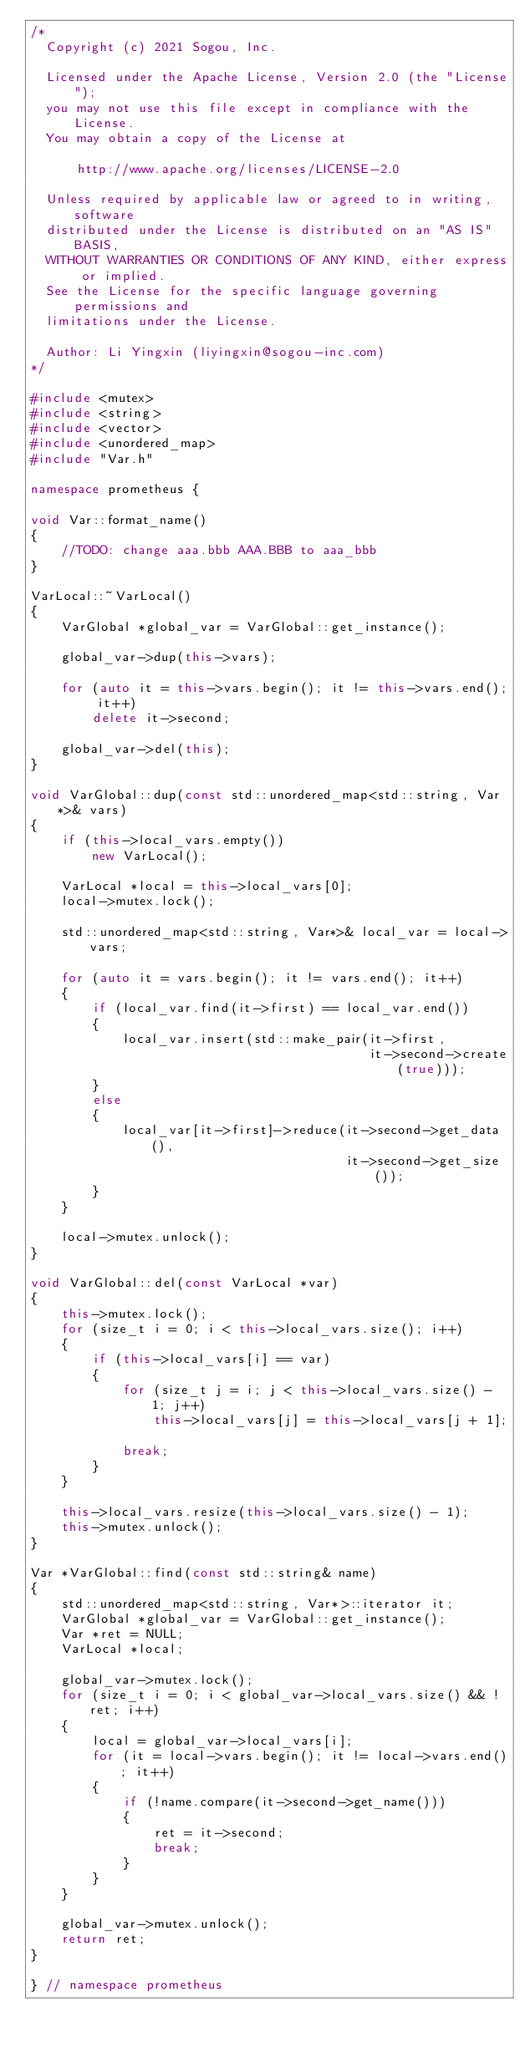Convert code to text. <code><loc_0><loc_0><loc_500><loc_500><_C++_>/*
  Copyright (c) 2021 Sogou, Inc.

  Licensed under the Apache License, Version 2.0 (the "License");
  you may not use this file except in compliance with the License.
  You may obtain a copy of the License at

      http://www.apache.org/licenses/LICENSE-2.0

  Unless required by applicable law or agreed to in writing, software
  distributed under the License is distributed on an "AS IS" BASIS,
  WITHOUT WARRANTIES OR CONDITIONS OF ANY KIND, either express or implied.
  See the License for the specific language governing permissions and
  limitations under the License.

  Author: Li Yingxin (liyingxin@sogou-inc.com)
*/

#include <mutex>
#include <string>
#include <vector>
#include <unordered_map>
#include "Var.h"

namespace prometheus {

void Var::format_name()
{
	//TODO: change aaa.bbb AAA.BBB to aaa_bbb
}

VarLocal::~VarLocal()
{
	VarGlobal *global_var = VarGlobal::get_instance();

	global_var->dup(this->vars);

	for (auto it = this->vars.begin(); it != this->vars.end(); it++)
		delete it->second;

	global_var->del(this);
}

void VarGlobal::dup(const std::unordered_map<std::string, Var *>& vars)
{
	if (this->local_vars.empty())
		new VarLocal();

	VarLocal *local = this->local_vars[0];
	local->mutex.lock();

	std::unordered_map<std::string, Var*>& local_var = local->vars;

	for (auto it = vars.begin(); it != vars.end(); it++)
	{
		if (local_var.find(it->first) == local_var.end())
		{
			local_var.insert(std::make_pair(it->first,
											it->second->create(true)));
		}
		else
		{
			local_var[it->first]->reduce(it->second->get_data(),
										 it->second->get_size());
		}
	}

	local->mutex.unlock();
}

void VarGlobal::del(const VarLocal *var)
{
	this->mutex.lock();
	for (size_t i = 0; i < this->local_vars.size(); i++)
	{
		if (this->local_vars[i] == var)
		{
			for (size_t j = i; j < this->local_vars.size() - 1; j++)
				this->local_vars[j] = this->local_vars[j + 1];

			break;
		}
	}

	this->local_vars.resize(this->local_vars.size() - 1);
	this->mutex.unlock();
}

Var *VarGlobal::find(const std::string& name)
{
	std::unordered_map<std::string, Var*>::iterator it;
	VarGlobal *global_var = VarGlobal::get_instance();
	Var *ret = NULL;
	VarLocal *local;

	global_var->mutex.lock();
	for (size_t i = 0; i < global_var->local_vars.size() && !ret; i++)
	{
		local = global_var->local_vars[i];
		for (it = local->vars.begin(); it != local->vars.end(); it++)
		{
			if (!name.compare(it->second->get_name()))
			{
				ret = it->second;
				break;
			}
		}
	}

	global_var->mutex.unlock();
	return ret;
}

} // namespace prometheus

</code> 